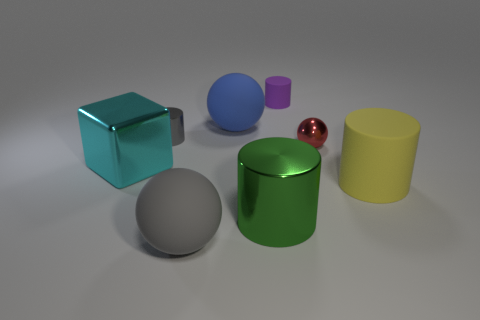Add 1 small shiny cylinders. How many objects exist? 9 Subtract all cubes. How many objects are left? 7 Add 1 tiny cylinders. How many tiny cylinders are left? 3 Add 5 brown objects. How many brown objects exist? 5 Subtract 0 red blocks. How many objects are left? 8 Subtract all small brown matte objects. Subtract all yellow cylinders. How many objects are left? 7 